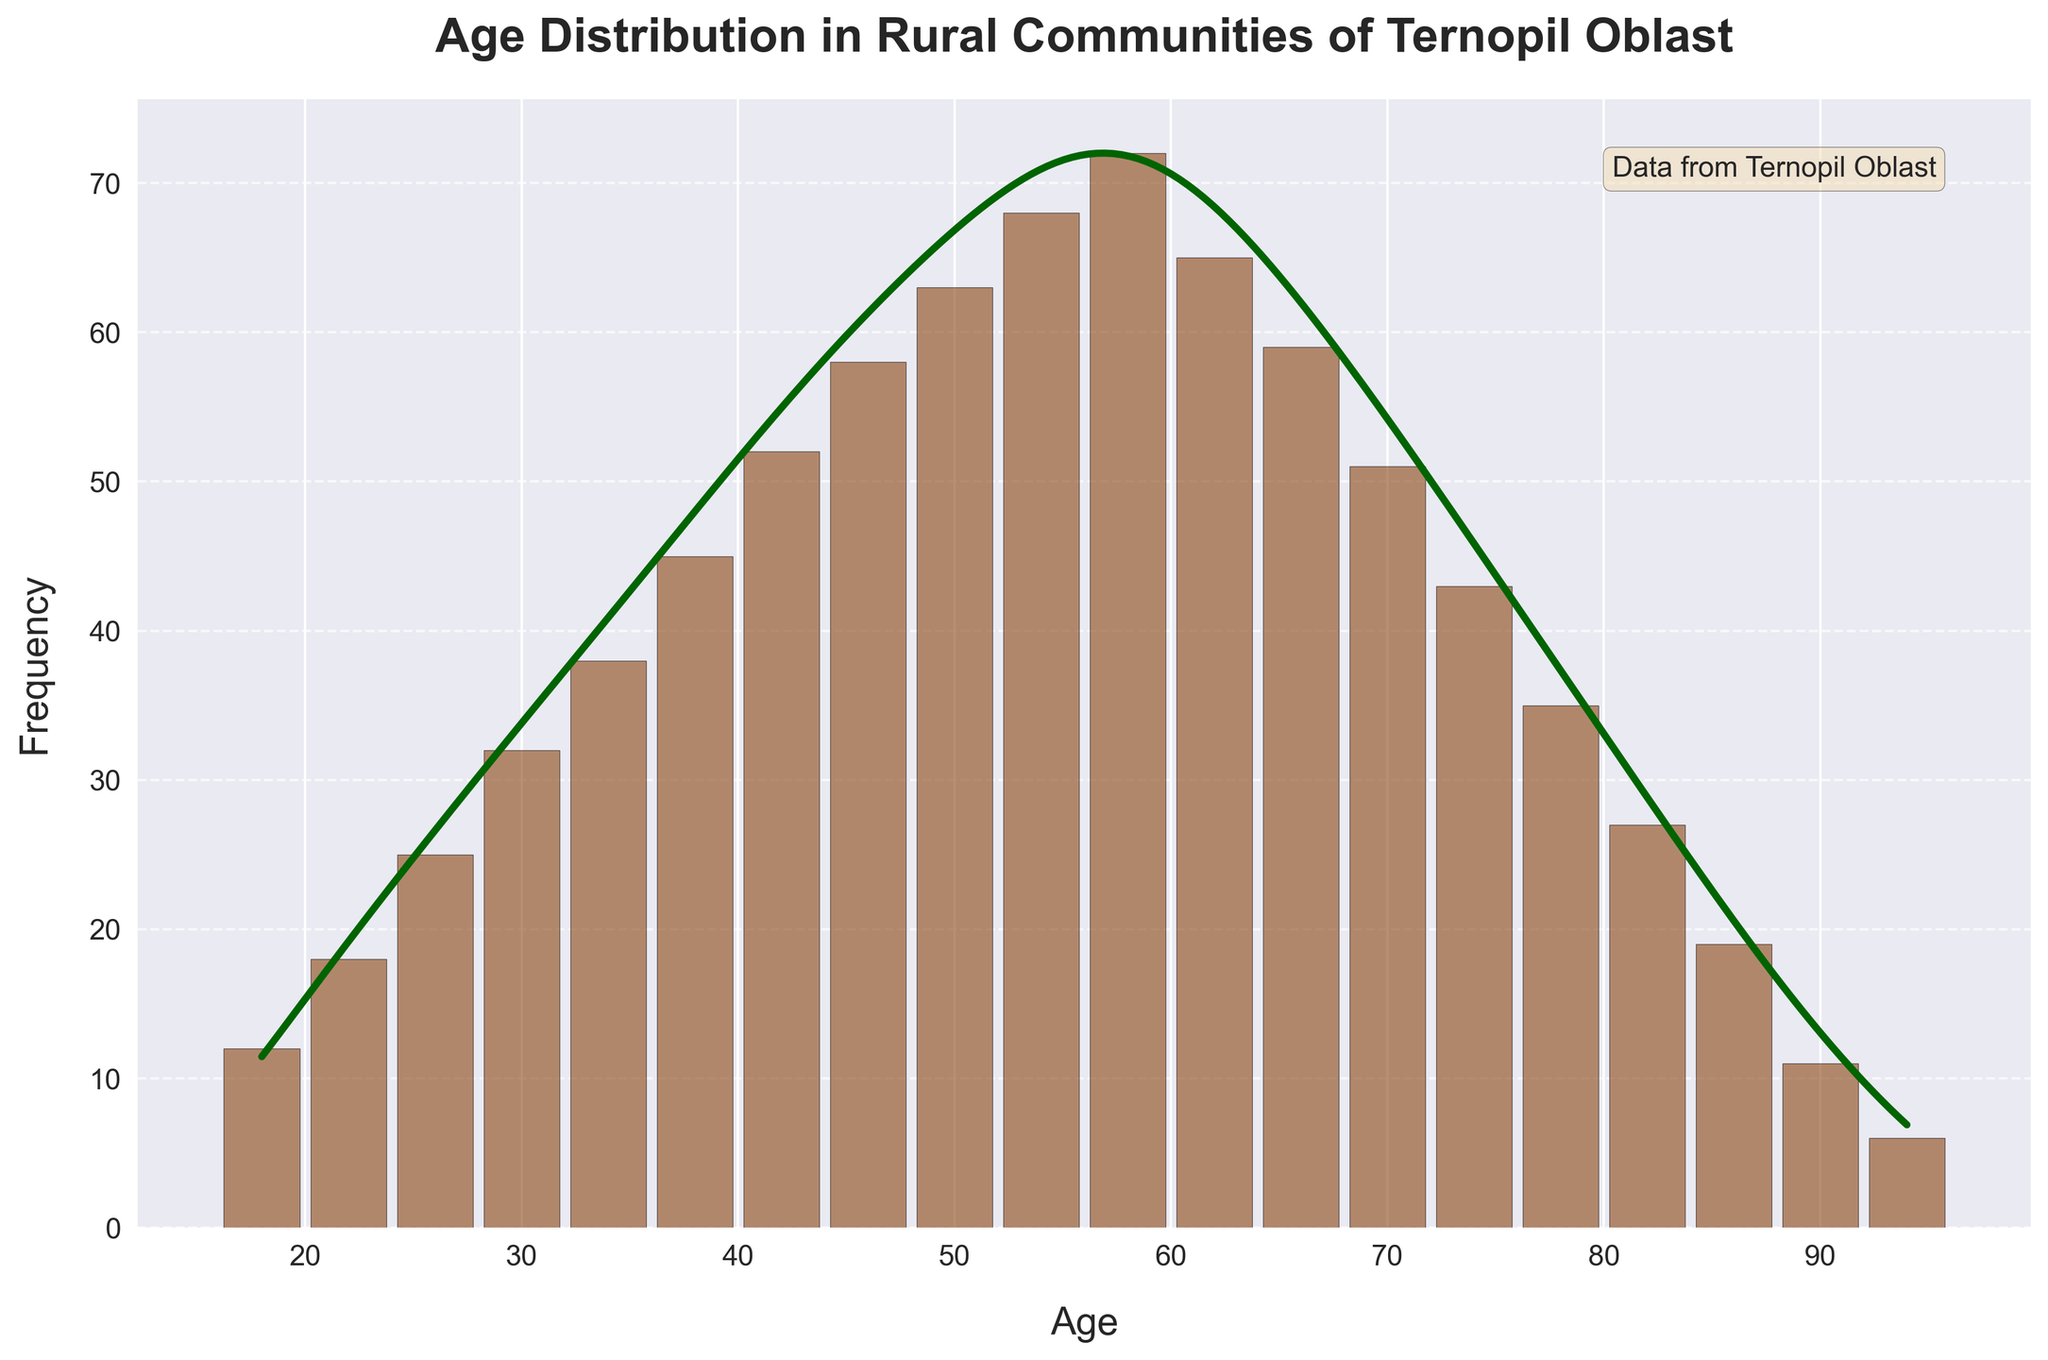What's the title of the plot? The title of the plot is written at the top of the figure. It reads "Age Distribution in Rural Communities of Ternopil Oblast."
Answer: Age Distribution in Rural Communities of Ternopil Oblast What do the x-axis and y-axis represent? The x-axis represents the age of the residents, while the y-axis represents the frequency of these ages. This is based on the labels given to each axis.
Answer: Age on the x-axis, Frequency on the y-axis Which age group has the highest frequency? By looking at the heights of the histogram bars, the age group 58 has the highest bar, indicating the highest frequency.
Answer: 58 What is the estimated peak of the KDE curve? The peak of the KDE curve appears at the same age where the highest bar of the histogram is located, which is around age 58.
Answer: Around age 58 How does the population frequency change from age 58 to age 78? From age 58, the frequency decreases as the age increases to 78. This is observed from the gradually decreasing heights of the histogram bars.
Answer: It decreases At what age does the frequency start to significantly drop? Observing the histogram, the frequency starts to significantly drop after age 58.
Answer: After age 58 Compare the frequency of the age groups 50 and 54. Which group is larger? The height of the histogram bar at age 54 is taller than that at age 50, indicating age 54 has a higher frequency.
Answer: Age 54 What is the approximate total frequency for ages over 70? Adding the frequencies for ages 70, 74, 78, 82, 86, 90, and 94: 51 + 43 + 35 + 27 + 19 + 11 + 6 = 192.
Answer: 192 Does the KDE curve show a single peak or multiple peaks? The KDE curve shows a single peak, indicating a unimodal distribution.
Answer: A single peak What is the trend observed in the age frequency distribution for residents aged 18 to 62? The frequency increases from age 18 to a peak at age 58, then begins to decrease as age approaches 62.
Answer: Increase to 58, then decrease 